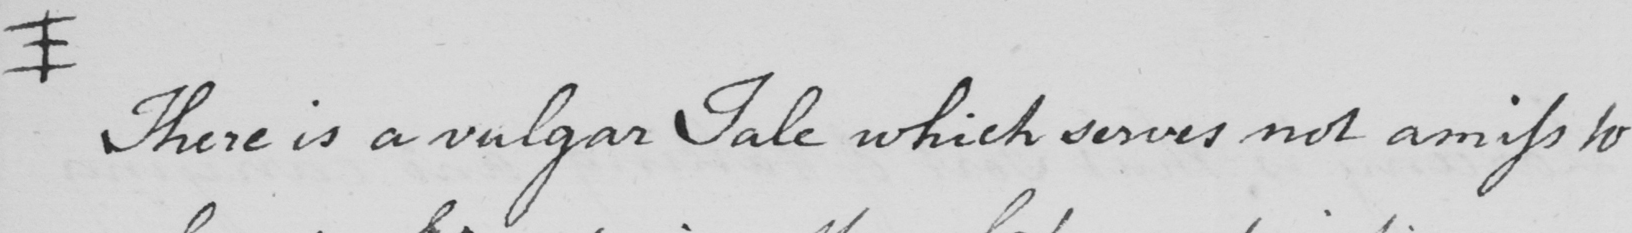What does this handwritten line say? +  There is a vulgar Tale which serves not amiss to 